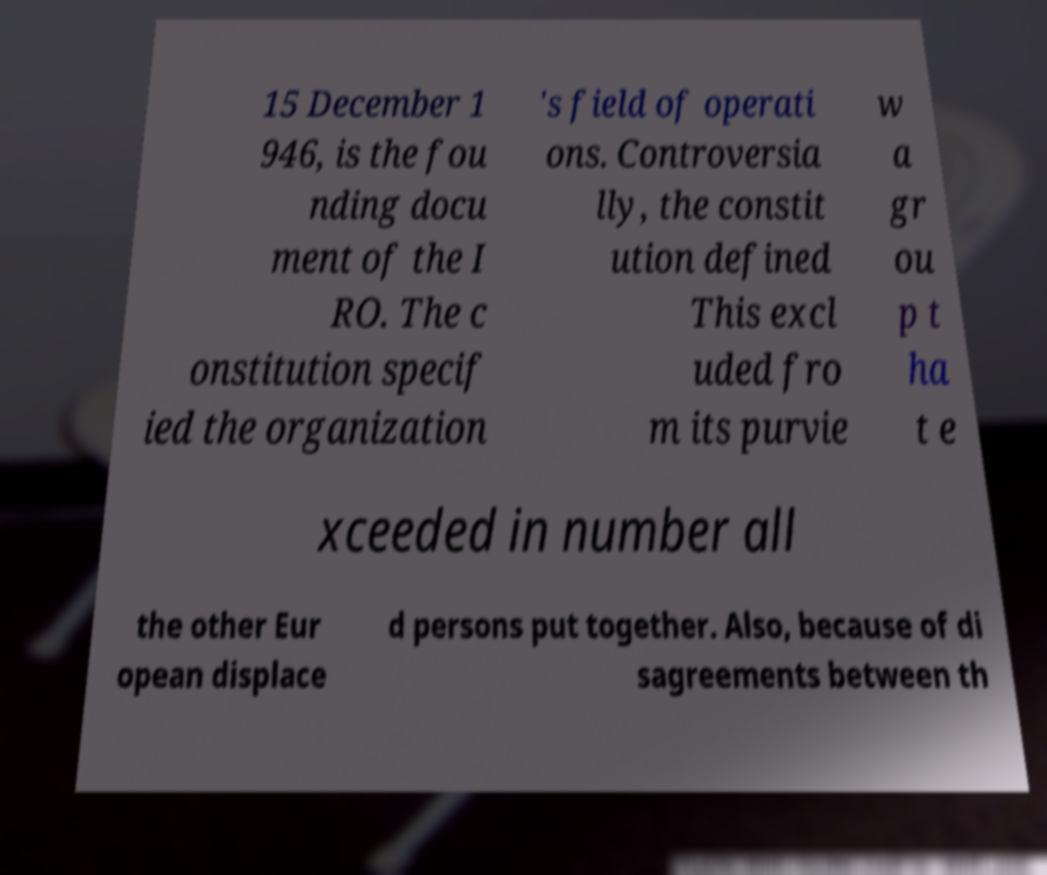What messages or text are displayed in this image? I need them in a readable, typed format. 15 December 1 946, is the fou nding docu ment of the I RO. The c onstitution specif ied the organization 's field of operati ons. Controversia lly, the constit ution defined This excl uded fro m its purvie w a gr ou p t ha t e xceeded in number all the other Eur opean displace d persons put together. Also, because of di sagreements between th 